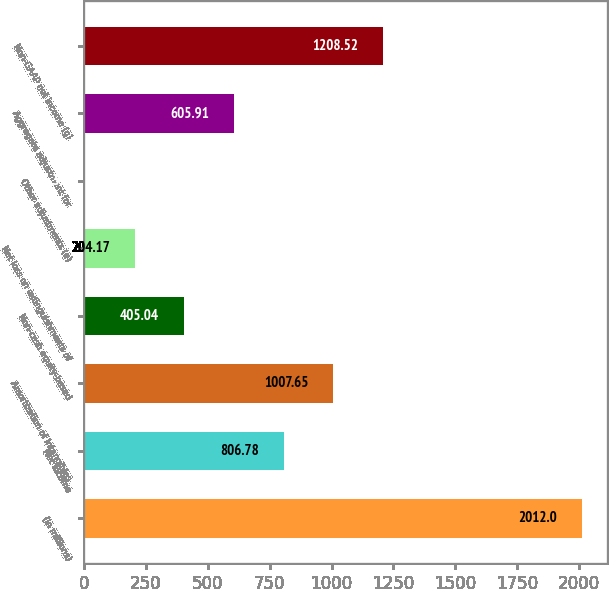Convert chart to OTSL. <chart><loc_0><loc_0><loc_500><loc_500><bar_chart><fcel>(in millions)<fcel>Net income<fcel>Amortization of intangibles<fcel>Non-cash equity-based<fcel>Net loss on extinguishments of<fcel>Other adjustments (e)<fcel>Aggregate adjustment for<fcel>Non-GAAP net income (g)<nl><fcel>2012<fcel>806.78<fcel>1007.65<fcel>405.04<fcel>204.17<fcel>3.3<fcel>605.91<fcel>1208.52<nl></chart> 